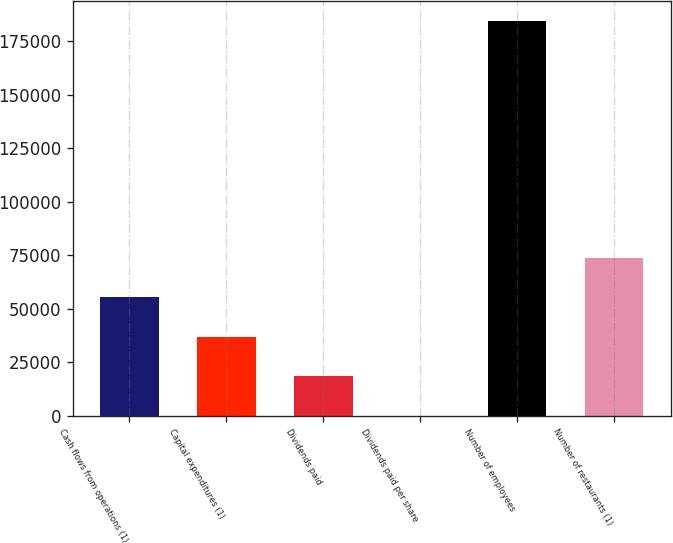Convert chart to OTSL. <chart><loc_0><loc_0><loc_500><loc_500><bar_chart><fcel>Cash flows from operations (1)<fcel>Capital expenditures (1)<fcel>Dividends paid<fcel>Dividends paid per share<fcel>Number of employees<fcel>Number of restaurants (1)<nl><fcel>55356.3<fcel>36905.2<fcel>18454.1<fcel>3<fcel>184514<fcel>73807.4<nl></chart> 